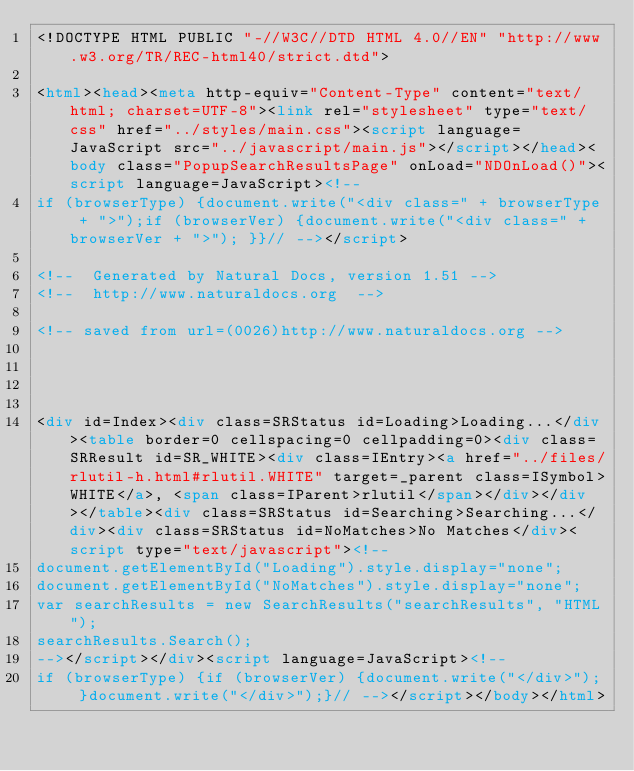<code> <loc_0><loc_0><loc_500><loc_500><_HTML_><!DOCTYPE HTML PUBLIC "-//W3C//DTD HTML 4.0//EN" "http://www.w3.org/TR/REC-html40/strict.dtd">

<html><head><meta http-equiv="Content-Type" content="text/html; charset=UTF-8"><link rel="stylesheet" type="text/css" href="../styles/main.css"><script language=JavaScript src="../javascript/main.js"></script></head><body class="PopupSearchResultsPage" onLoad="NDOnLoad()"><script language=JavaScript><!--
if (browserType) {document.write("<div class=" + browserType + ">");if (browserVer) {document.write("<div class=" + browserVer + ">"); }}// --></script>

<!--  Generated by Natural Docs, version 1.51 -->
<!--  http://www.naturaldocs.org  -->

<!-- saved from url=(0026)http://www.naturaldocs.org -->




<div id=Index><div class=SRStatus id=Loading>Loading...</div><table border=0 cellspacing=0 cellpadding=0><div class=SRResult id=SR_WHITE><div class=IEntry><a href="../files/rlutil-h.html#rlutil.WHITE" target=_parent class=ISymbol>WHITE</a>, <span class=IParent>rlutil</span></div></div></table><div class=SRStatus id=Searching>Searching...</div><div class=SRStatus id=NoMatches>No Matches</div><script type="text/javascript"><!--
document.getElementById("Loading").style.display="none";
document.getElementById("NoMatches").style.display="none";
var searchResults = new SearchResults("searchResults", "HTML");
searchResults.Search();
--></script></div><script language=JavaScript><!--
if (browserType) {if (browserVer) {document.write("</div>"); }document.write("</div>");}// --></script></body></html></code> 